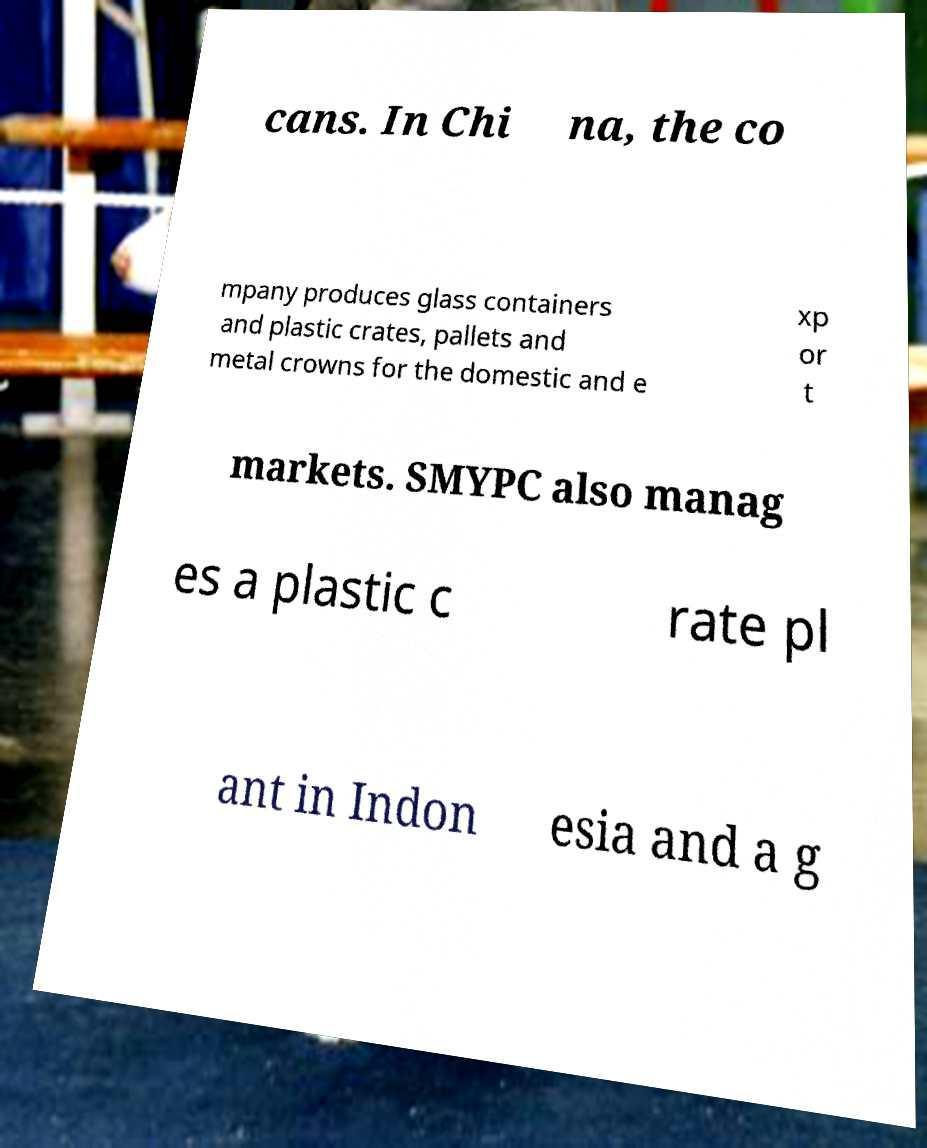What messages or text are displayed in this image? I need them in a readable, typed format. cans. In Chi na, the co mpany produces glass containers and plastic crates, pallets and metal crowns for the domestic and e xp or t markets. SMYPC also manag es a plastic c rate pl ant in Indon esia and a g 